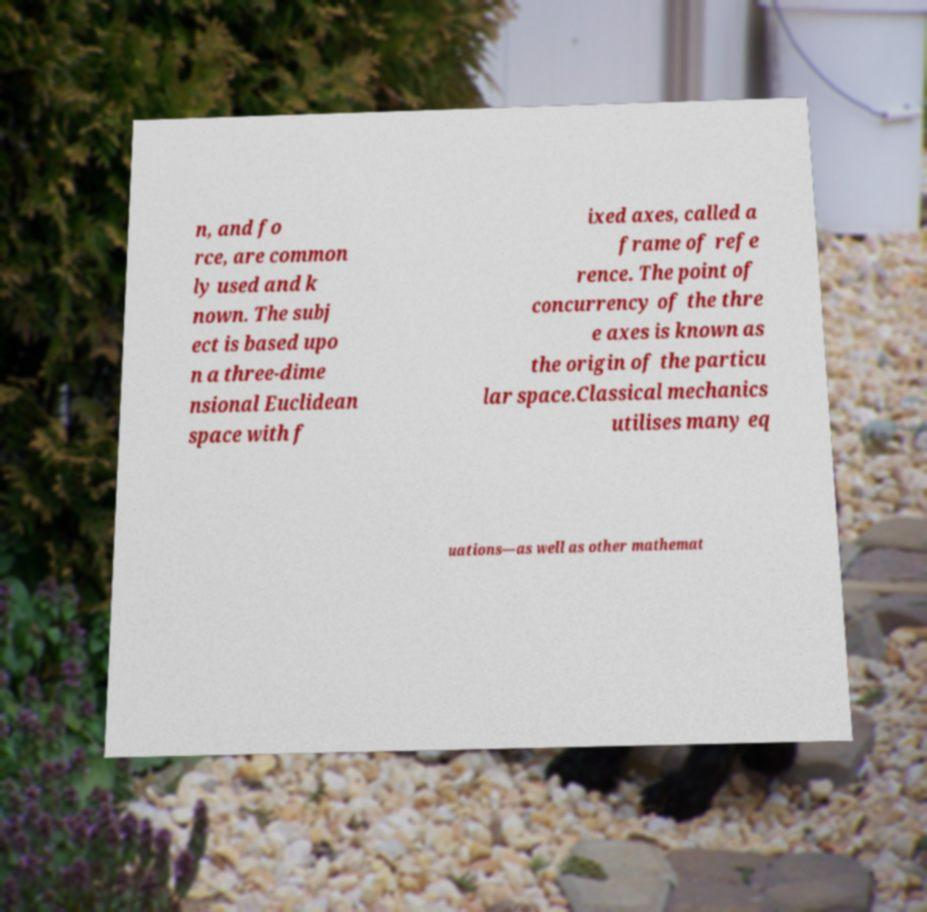I need the written content from this picture converted into text. Can you do that? n, and fo rce, are common ly used and k nown. The subj ect is based upo n a three-dime nsional Euclidean space with f ixed axes, called a frame of refe rence. The point of concurrency of the thre e axes is known as the origin of the particu lar space.Classical mechanics utilises many eq uations—as well as other mathemat 